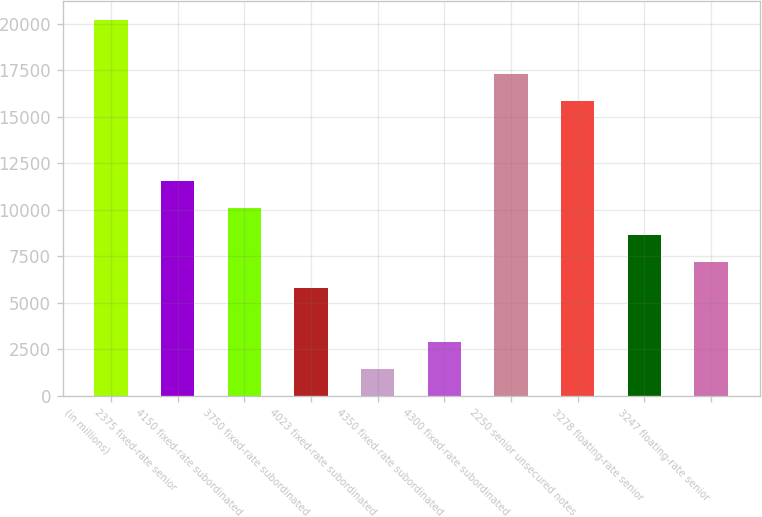Convert chart to OTSL. <chart><loc_0><loc_0><loc_500><loc_500><bar_chart><fcel>(in millions)<fcel>2375 fixed-rate senior<fcel>4150 fixed-rate subordinated<fcel>3750 fixed-rate subordinated<fcel>4023 fixed-rate subordinated<fcel>4350 fixed-rate subordinated<fcel>4300 fixed-rate subordinated<fcel>2250 senior unsecured notes<fcel>3278 floating-rate senior<fcel>3247 floating-rate senior<nl><fcel>20202.6<fcel>11548.2<fcel>10105.8<fcel>5778.6<fcel>1451.4<fcel>2893.8<fcel>17317.8<fcel>15875.4<fcel>8663.4<fcel>7221<nl></chart> 